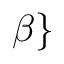Convert formula to latex. <formula><loc_0><loc_0><loc_500><loc_500>\beta \}</formula> 